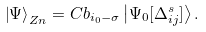<formula> <loc_0><loc_0><loc_500><loc_500>\left | \Psi \right \rangle _ { Z n } = C b _ { i _ { 0 } - \sigma } \left | \Psi _ { 0 } [ \Delta _ { i j } ^ { s } ] \right \rangle .</formula> 